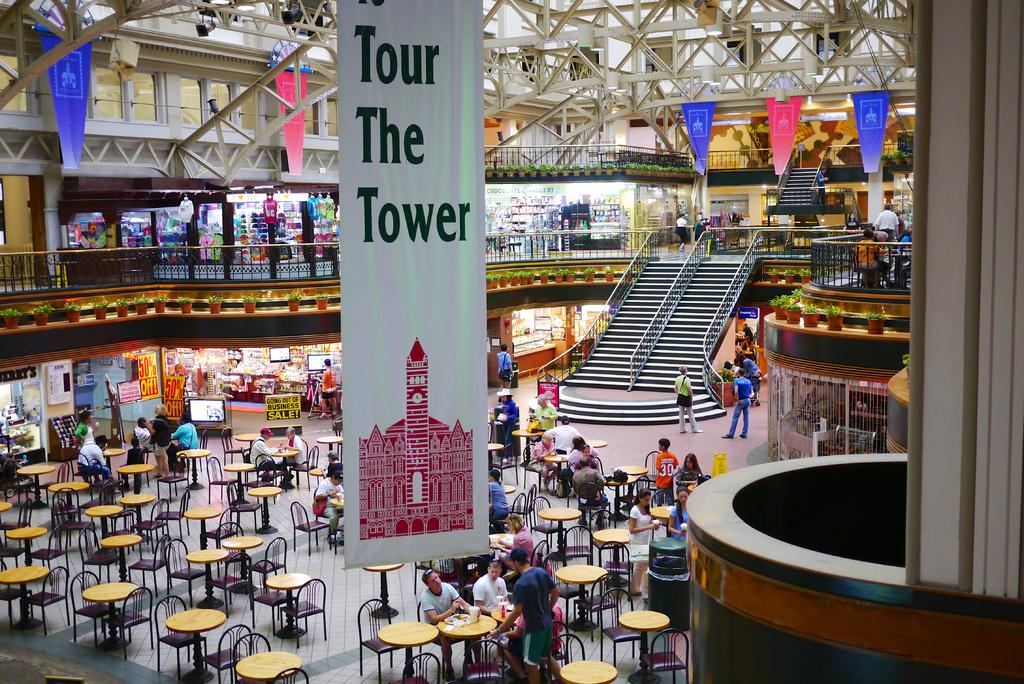<image>
Offer a succinct explanation of the picture presented. a cafeteria with tables and a sign reading 'tour the tower' 